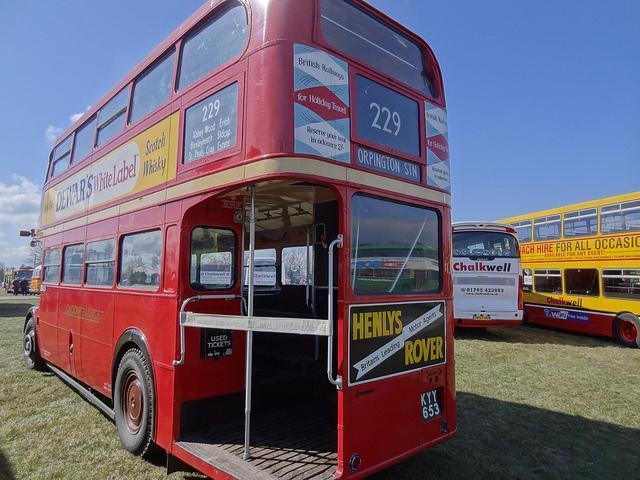How many wheels are visible?
Give a very brief answer. 2. How many buses are there?
Give a very brief answer. 3. How many people are sitting on a toilet?
Give a very brief answer. 0. 